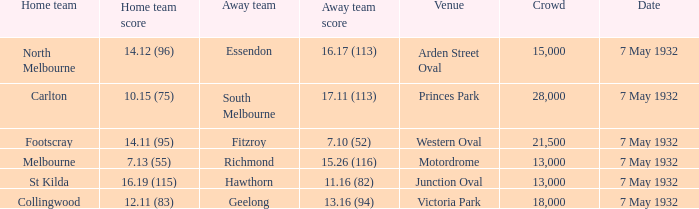Write the full table. {'header': ['Home team', 'Home team score', 'Away team', 'Away team score', 'Venue', 'Crowd', 'Date'], 'rows': [['North Melbourne', '14.12 (96)', 'Essendon', '16.17 (113)', 'Arden Street Oval', '15,000', '7 May 1932'], ['Carlton', '10.15 (75)', 'South Melbourne', '17.11 (113)', 'Princes Park', '28,000', '7 May 1932'], ['Footscray', '14.11 (95)', 'Fitzroy', '7.10 (52)', 'Western Oval', '21,500', '7 May 1932'], ['Melbourne', '7.13 (55)', 'Richmond', '15.26 (116)', 'Motordrome', '13,000', '7 May 1932'], ['St Kilda', '16.19 (115)', 'Hawthorn', '11.16 (82)', 'Junction Oval', '13,000', '7 May 1932'], ['Collingwood', '12.11 (83)', 'Geelong', '13.16 (94)', 'Victoria Park', '18,000', '7 May 1932']]} What is the total of crowd with Home team score of 14.12 (96)? 15000.0. 